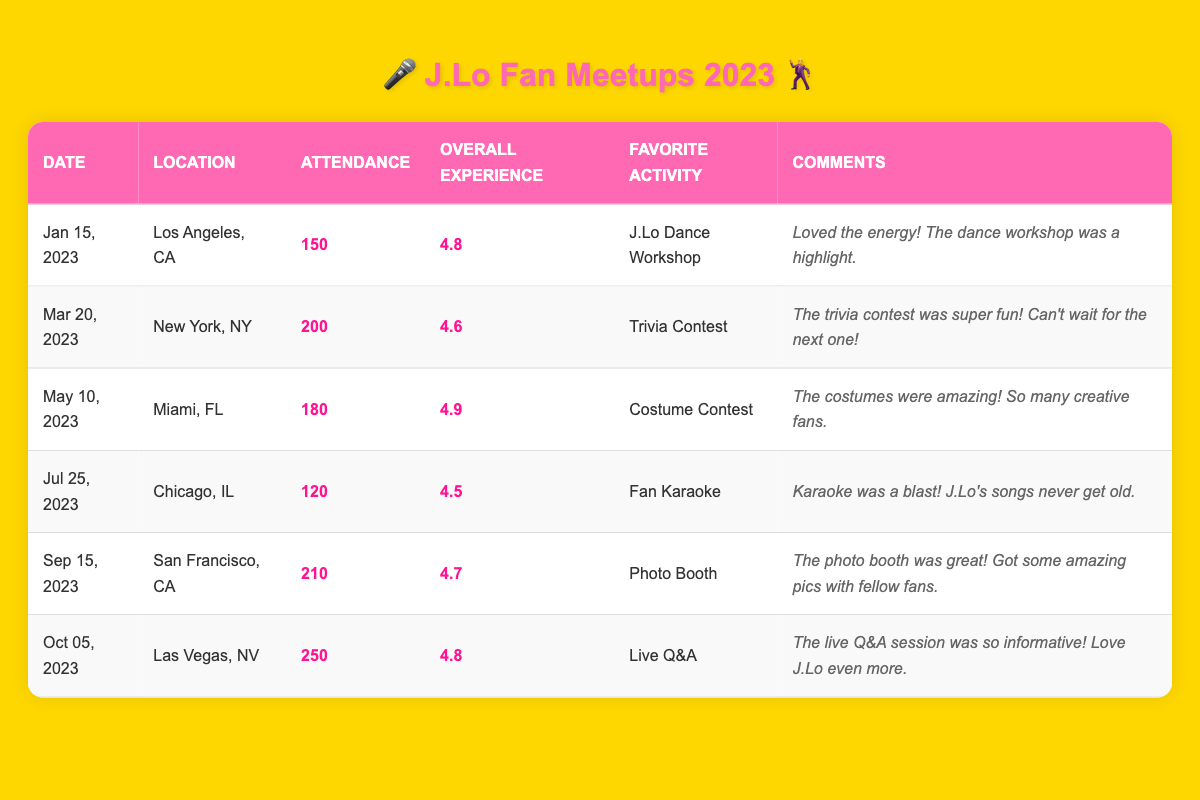What was the total attendance at all the meetups in 2023? To find the total attendance, we add the attendance figures from all meetups: 150 + 200 + 180 + 120 + 210 + 250 = 1110.
Answer: 1110 Which city had the highest attendance at a meetup? The highest attendance is 250, which occurs in Las Vegas.
Answer: Las Vegas What was the overall experience rating for the Miami meetup? The overall experience rating for the Miami meetup on May 10, 2023, is 4.9.
Answer: 4.9 How many meetups had an overall experience rating of 4.7 or higher? The meetups with ratings of 4.7 or higher are in Los Angeles (4.8), Miami (4.9), San Francisco (4.7), and Las Vegas (4.8), tallying up to 4 meetups.
Answer: 4 What was the favorite activity during the Chicago meetup? The favorite activity during the Chicago meetup on July 25, 2023, was Fan Karaoke.
Answer: Fan Karaoke Is it true that the New York meetup had more attendees than the Chicago meetup? Comparing the attendance, New York had 200 attendees and Chicago had 120 attendees, so yes, New York had more attendees.
Answer: Yes What was the difference in attendance between the San Francisco and Los Angeles meetups? The attendance for San Francisco was 210 and for Los Angeles was 150. The difference is 210 - 150 = 60.
Answer: 60 What is the average overall experience rating for all meetups? First, we sum the ratings: 4.8 + 4.6 + 4.9 + 4.5 + 4.7 + 4.8 = 29.3. There are 6 meetups, so the average is 29.3 / 6 = 4.8833, which rounds to 4.88.
Answer: 4.88 Which meetup received comments about the costumes being amazing? The comments about amazing costumes were given for the Miami meetup held on May 10, 2023.
Answer: Miami How does the overall experience rating of the Trivia Contest in New York compare to that of the Live Q&A in Las Vegas? The overall experience rating for the Trivia Contest in New York is 4.6, while it's 4.8 for the Live Q&A in Las Vegas. Since 4.8 is greater than 4.6, the Live Q&A had a better rating.
Answer: Live Q&A was better 